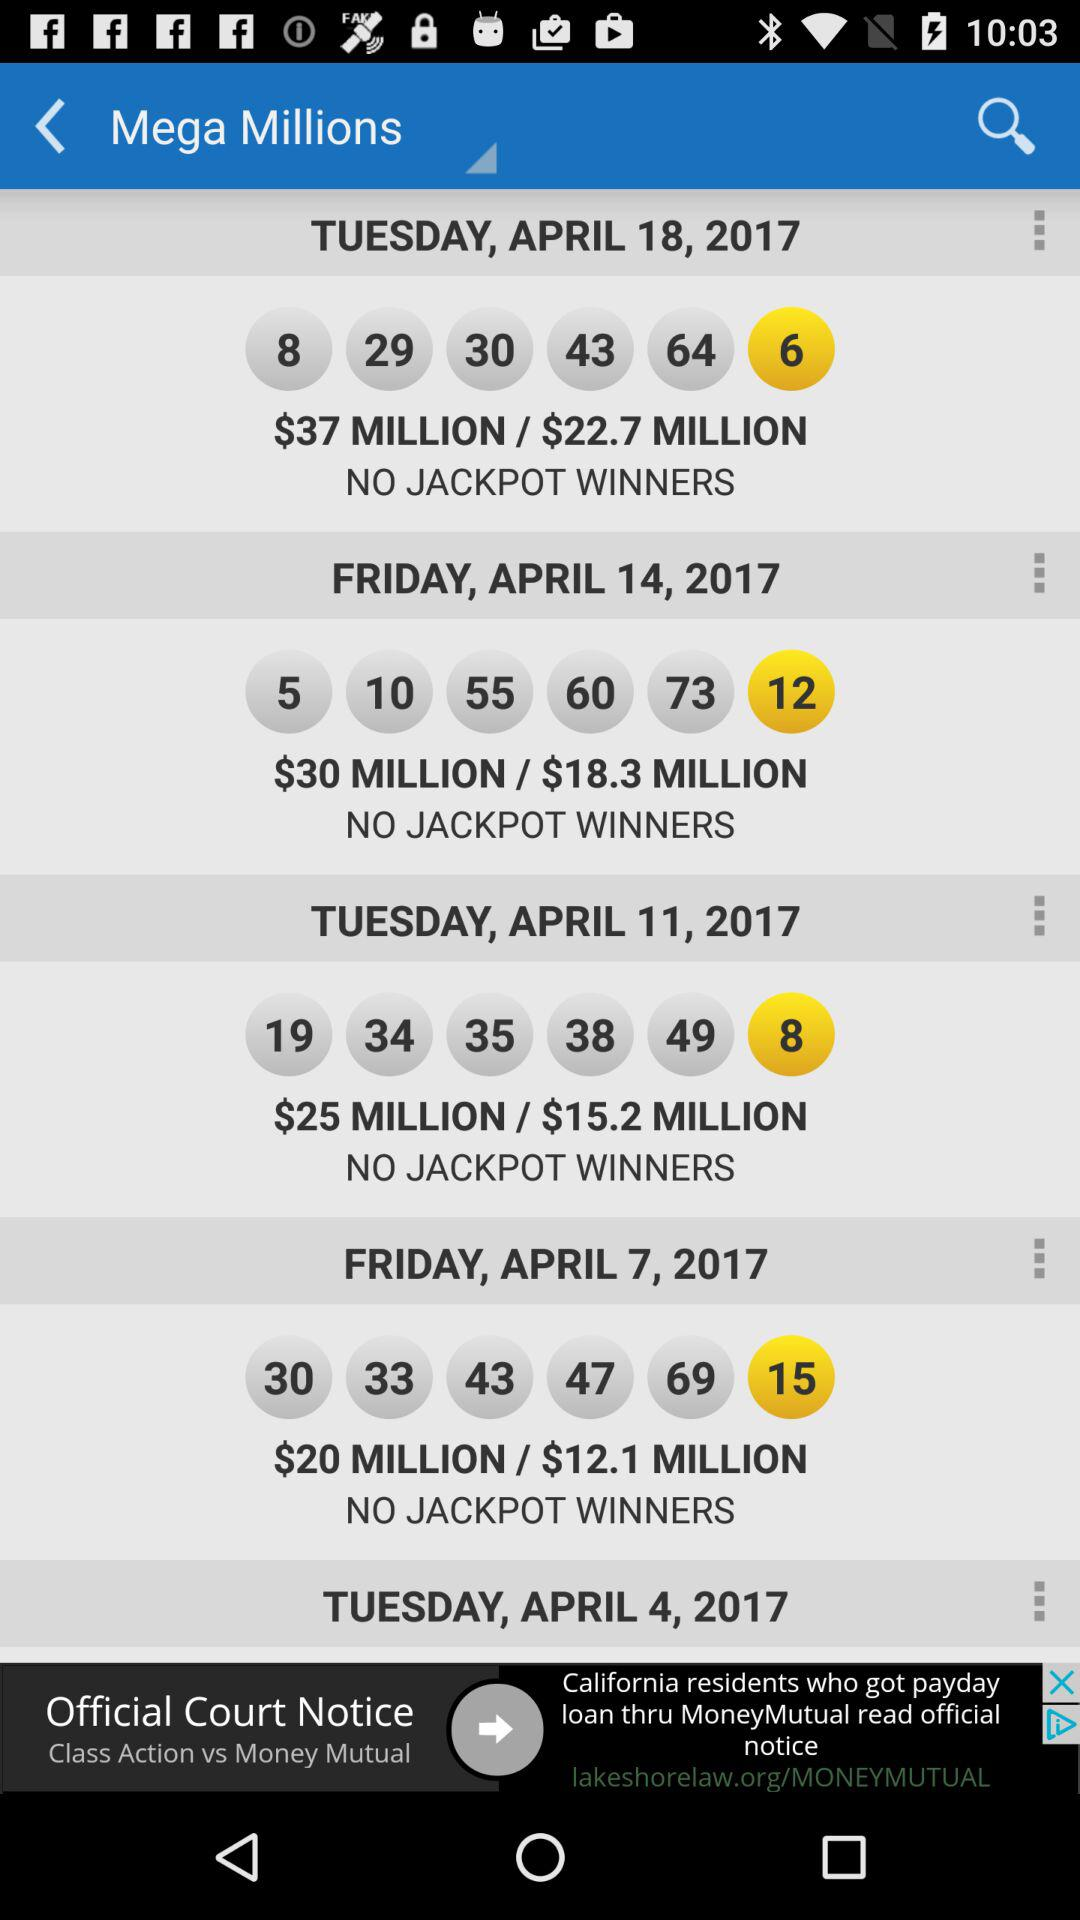What is the jackpot price on April 7, 2017? The jackpot price is $20 million. 